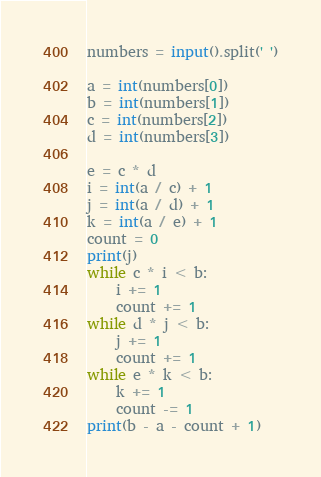<code> <loc_0><loc_0><loc_500><loc_500><_Python_>numbers = input().split(' ')

a = int(numbers[0])	
b = int(numbers[1])
c = int(numbers[2])
d = int(numbers[3])

e = c * d
i = int(a / c) + 1
j = int(a / d) + 1
k = int(a / e) + 1
count = 0
print(j)
while c * i < b:
	i += 1
	count += 1
while d * j < b:
	j += 1
	count += 1
while e * k < b:
	k += 1
	count -= 1
print(b - a - count + 1)
</code> 